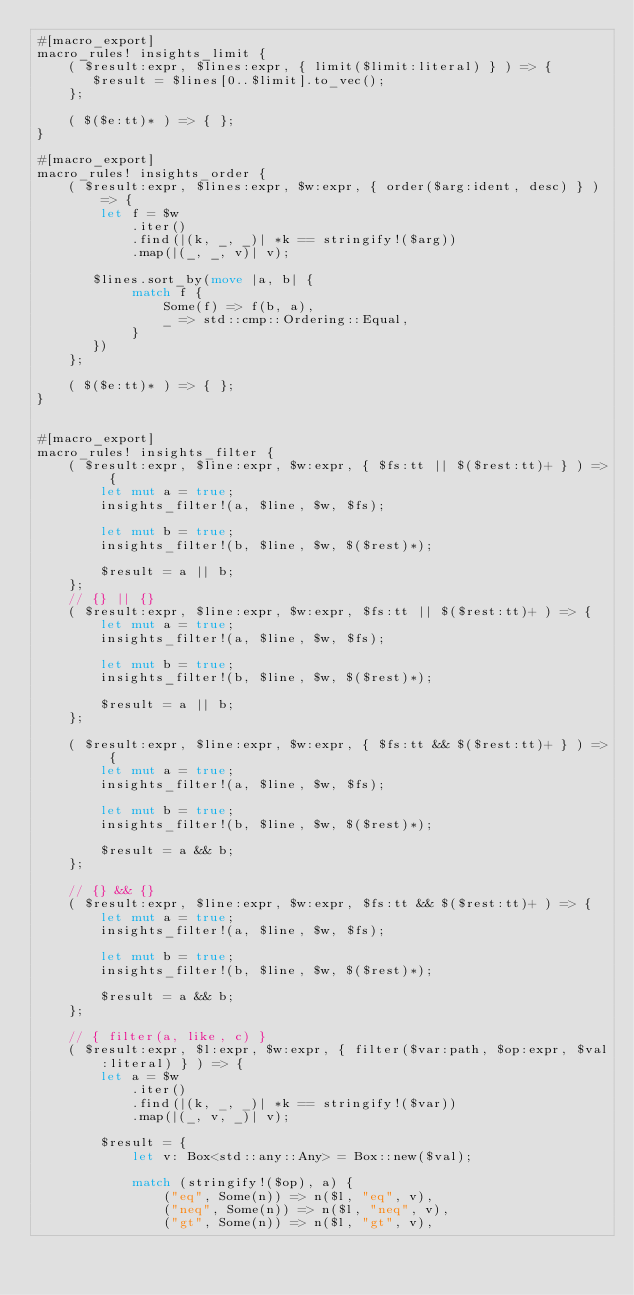Convert code to text. <code><loc_0><loc_0><loc_500><loc_500><_Rust_>#[macro_export]
macro_rules! insights_limit {
    ( $result:expr, $lines:expr, { limit($limit:literal) } ) => {
       $result = $lines[0..$limit].to_vec();
    };
    
    ( $($e:tt)* ) => { };
}    

#[macro_export]
macro_rules! insights_order {
    ( $result:expr, $lines:expr, $w:expr, { order($arg:ident, desc) } ) => {
        let f = $w
            .iter()
            .find(|(k, _, _)| *k == stringify!($arg))
            .map(|(_, _, v)| v);

       $lines.sort_by(move |a, b| {
            match f {
                Some(f) => f(b, a),
                _ => std::cmp::Ordering::Equal,
            }
       })
    };
    
    ( $($e:tt)* ) => { };
}    


#[macro_export]
macro_rules! insights_filter {
    ( $result:expr, $line:expr, $w:expr, { $fs:tt || $($rest:tt)+ } ) => { 
        let mut a = true;
        insights_filter!(a, $line, $w, $fs);

        let mut b = true;
        insights_filter!(b, $line, $w, $($rest)*);

        $result = a || b;
    };
    // {} || {}
    ( $result:expr, $line:expr, $w:expr, $fs:tt || $($rest:tt)+ ) => {
        let mut a = true;
        insights_filter!(a, $line, $w, $fs);

        let mut b = true;
        insights_filter!(b, $line, $w, $($rest)*);

        $result = a || b;
    };

    ( $result:expr, $line:expr, $w:expr, { $fs:tt && $($rest:tt)+ } ) => { 
        let mut a = true;
        insights_filter!(a, $line, $w, $fs);

        let mut b = true;
        insights_filter!(b, $line, $w, $($rest)*);

        $result = a && b;
    };
    
    // {} && {}
    ( $result:expr, $line:expr, $w:expr, $fs:tt && $($rest:tt)+ ) => {
        let mut a = true;
        insights_filter!(a, $line, $w, $fs);

        let mut b = true;
        insights_filter!(b, $line, $w, $($rest)*);

        $result = a && b;
    };

    // { filter(a, like, c) }
    ( $result:expr, $l:expr, $w:expr, { filter($var:path, $op:expr, $val:literal) } ) => {
        let a = $w
            .iter()
            .find(|(k, _, _)| *k == stringify!($var))
            .map(|(_, v, _)| v);

        $result = {
            let v: Box<std::any::Any> = Box::new($val);

            match (stringify!($op), a) {
                ("eq", Some(n)) => n($l, "eq", v),
                ("neq", Some(n)) => n($l, "neq", v),
                ("gt", Some(n)) => n($l, "gt", v),</code> 